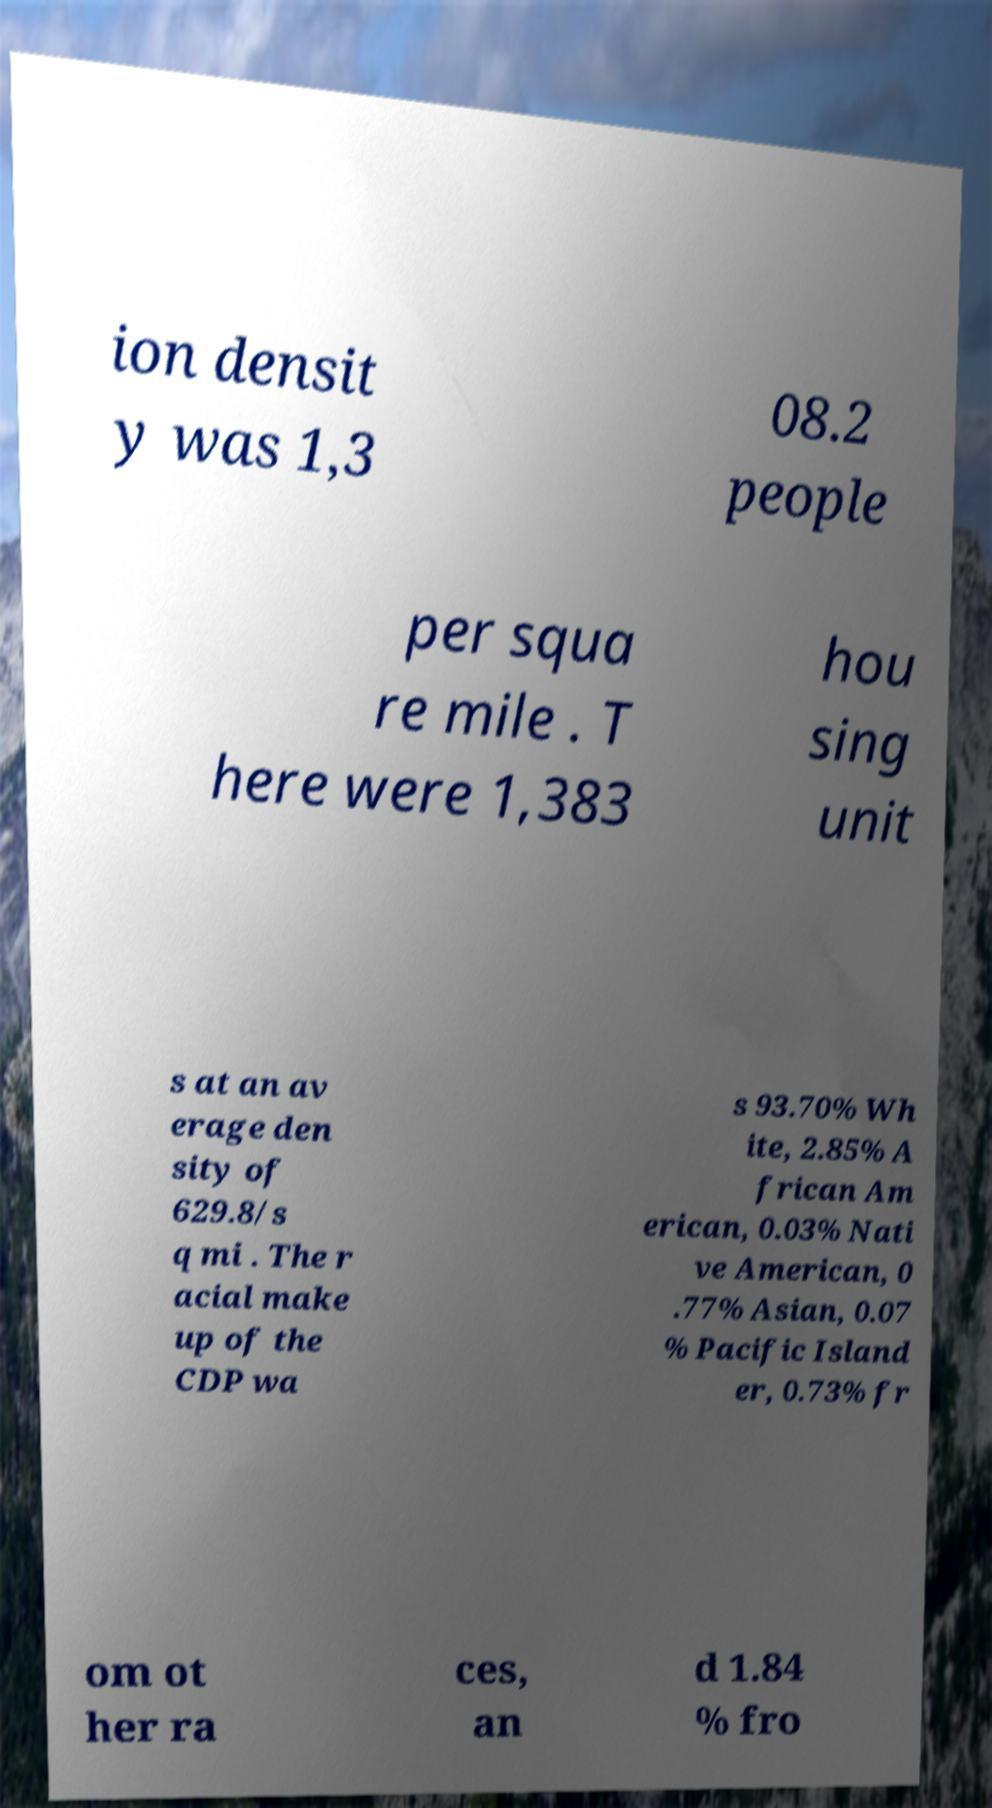Please read and relay the text visible in this image. What does it say? ion densit y was 1,3 08.2 people per squa re mile . T here were 1,383 hou sing unit s at an av erage den sity of 629.8/s q mi . The r acial make up of the CDP wa s 93.70% Wh ite, 2.85% A frican Am erican, 0.03% Nati ve American, 0 .77% Asian, 0.07 % Pacific Island er, 0.73% fr om ot her ra ces, an d 1.84 % fro 